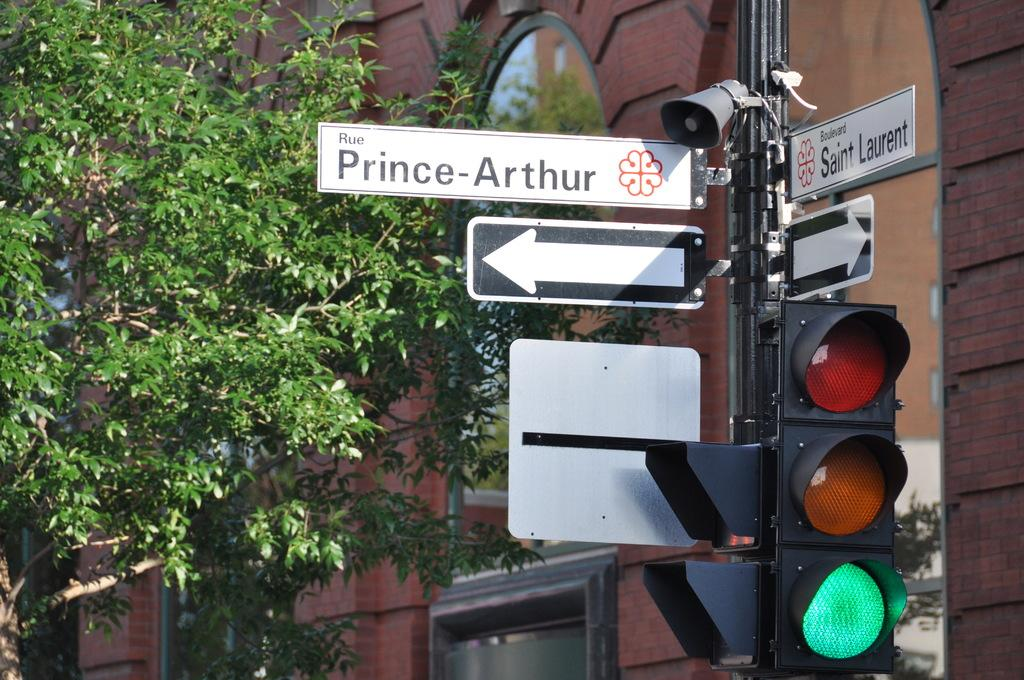<image>
Offer a succinct explanation of the picture presented. The corner of Prince-Arthur and Saint Laurent shows a green light. 